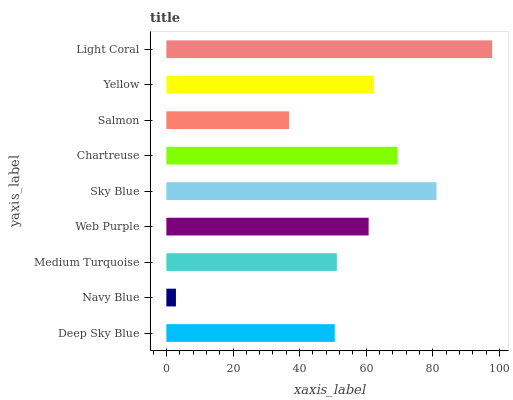Is Navy Blue the minimum?
Answer yes or no. Yes. Is Light Coral the maximum?
Answer yes or no. Yes. Is Medium Turquoise the minimum?
Answer yes or no. No. Is Medium Turquoise the maximum?
Answer yes or no. No. Is Medium Turquoise greater than Navy Blue?
Answer yes or no. Yes. Is Navy Blue less than Medium Turquoise?
Answer yes or no. Yes. Is Navy Blue greater than Medium Turquoise?
Answer yes or no. No. Is Medium Turquoise less than Navy Blue?
Answer yes or no. No. Is Web Purple the high median?
Answer yes or no. Yes. Is Web Purple the low median?
Answer yes or no. Yes. Is Medium Turquoise the high median?
Answer yes or no. No. Is Chartreuse the low median?
Answer yes or no. No. 